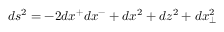<formula> <loc_0><loc_0><loc_500><loc_500>d s ^ { 2 } = - 2 d x ^ { + } d x ^ { - } + d x ^ { 2 } + d z ^ { 2 } + d x _ { \perp } ^ { 2 }</formula> 